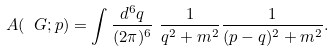<formula> <loc_0><loc_0><loc_500><loc_500>A ( \ G ; p ) & = \int \frac { d ^ { 6 } q } { ( 2 \pi ) ^ { 6 } } \ \frac { 1 } { q ^ { 2 } + m ^ { 2 } } \frac { 1 } { ( p - q ) ^ { 2 } + m ^ { 2 } } .</formula> 